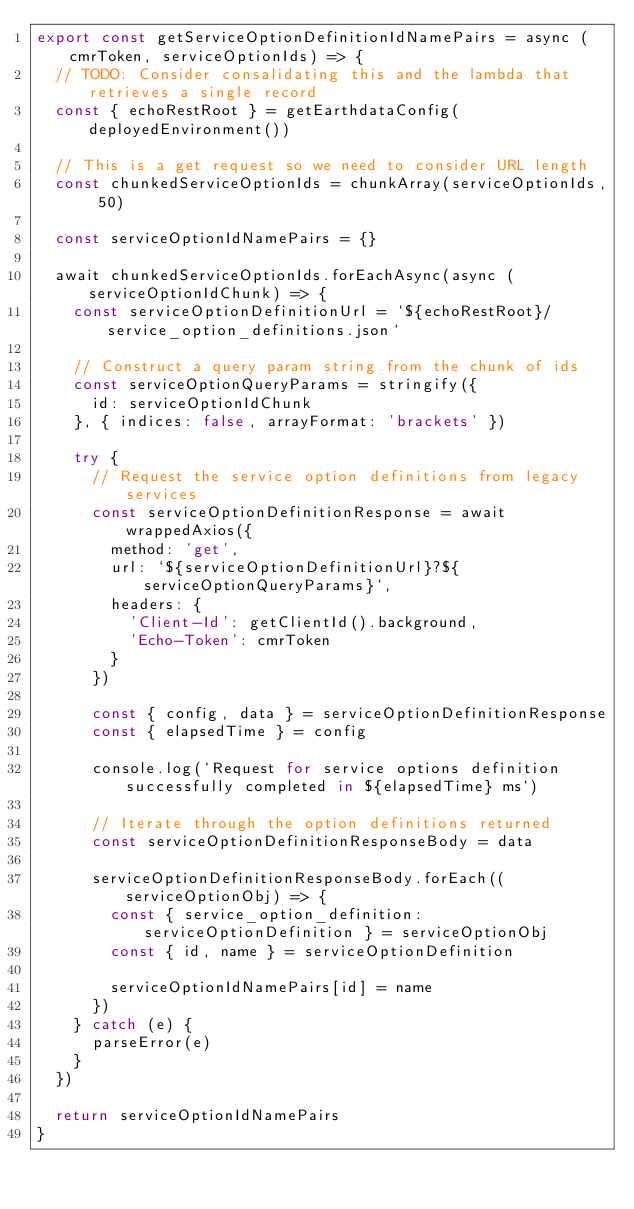<code> <loc_0><loc_0><loc_500><loc_500><_JavaScript_>export const getServiceOptionDefinitionIdNamePairs = async (cmrToken, serviceOptionIds) => {
  // TODO: Consider consalidating this and the lambda that retrieves a single record
  const { echoRestRoot } = getEarthdataConfig(deployedEnvironment())

  // This is a get request so we need to consider URL length
  const chunkedServiceOptionIds = chunkArray(serviceOptionIds, 50)

  const serviceOptionIdNamePairs = {}

  await chunkedServiceOptionIds.forEachAsync(async (serviceOptionIdChunk) => {
    const serviceOptionDefinitionUrl = `${echoRestRoot}/service_option_definitions.json`

    // Construct a query param string from the chunk of ids
    const serviceOptionQueryParams = stringify({
      id: serviceOptionIdChunk
    }, { indices: false, arrayFormat: 'brackets' })

    try {
      // Request the service option definitions from legacy services
      const serviceOptionDefinitionResponse = await wrappedAxios({
        method: 'get',
        url: `${serviceOptionDefinitionUrl}?${serviceOptionQueryParams}`,
        headers: {
          'Client-Id': getClientId().background,
          'Echo-Token': cmrToken
        }
      })

      const { config, data } = serviceOptionDefinitionResponse
      const { elapsedTime } = config

      console.log(`Request for service options definition successfully completed in ${elapsedTime} ms`)

      // Iterate through the option definitions returned
      const serviceOptionDefinitionResponseBody = data

      serviceOptionDefinitionResponseBody.forEach((serviceOptionObj) => {
        const { service_option_definition: serviceOptionDefinition } = serviceOptionObj
        const { id, name } = serviceOptionDefinition

        serviceOptionIdNamePairs[id] = name
      })
    } catch (e) {
      parseError(e)
    }
  })

  return serviceOptionIdNamePairs
}
</code> 